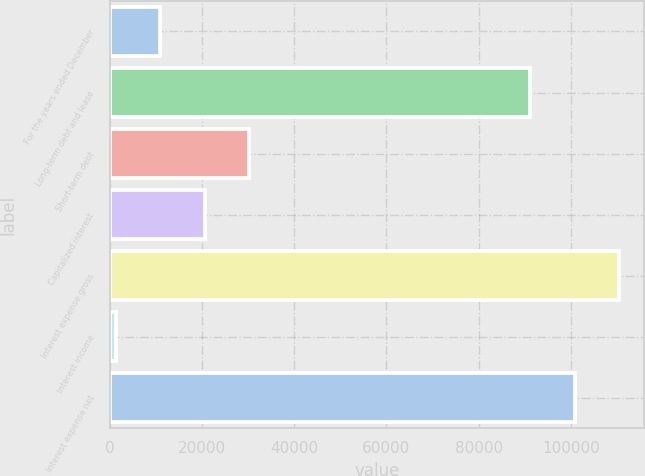Convert chart. <chart><loc_0><loc_0><loc_500><loc_500><bar_chart><fcel>For the years ended December<fcel>Long-term debt and lease<fcel>Short-term debt<fcel>Capitalized interest<fcel>Interest expense gross<fcel>Interest income<fcel>Interest expense net<nl><fcel>10913.4<fcel>91144<fcel>30200.2<fcel>20556.8<fcel>110431<fcel>1270<fcel>100787<nl></chart> 